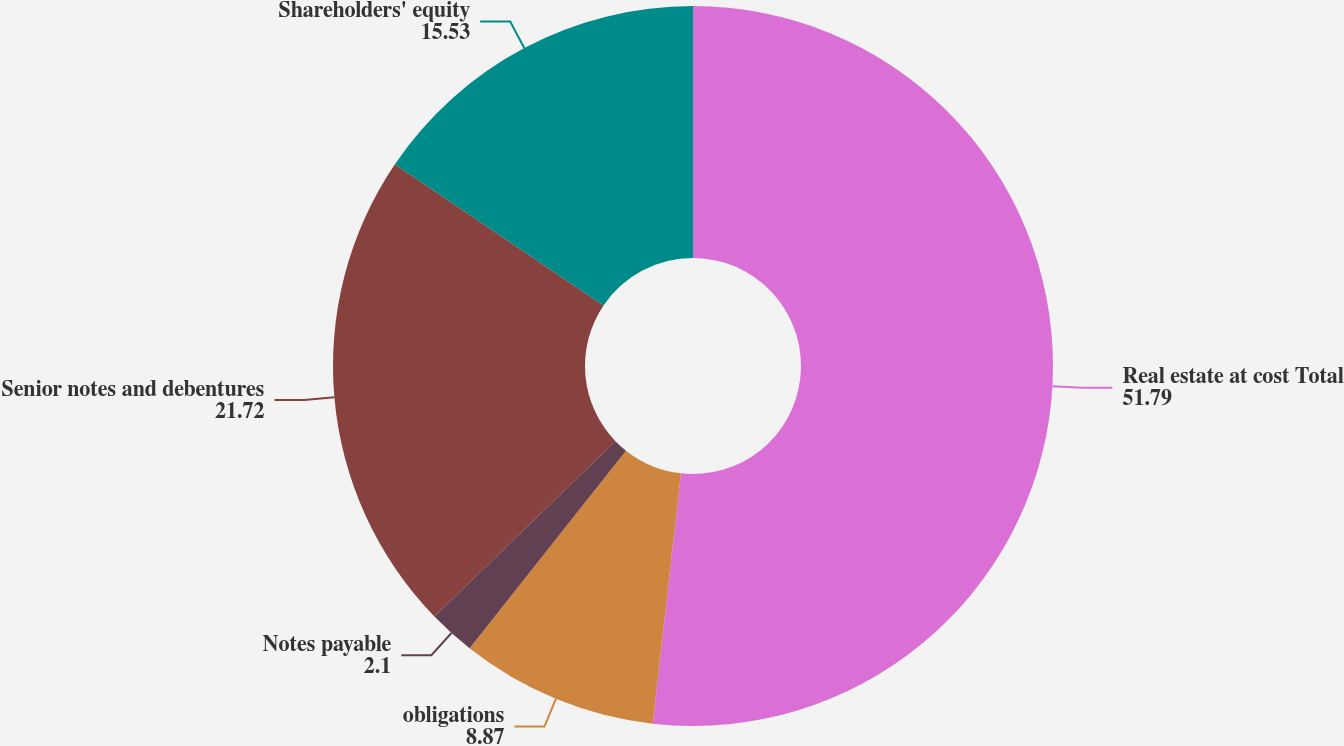Convert chart. <chart><loc_0><loc_0><loc_500><loc_500><pie_chart><fcel>Real estate at cost Total<fcel>obligations<fcel>Notes payable<fcel>Senior notes and debentures<fcel>Shareholders' equity<nl><fcel>51.79%<fcel>8.87%<fcel>2.1%<fcel>21.72%<fcel>15.53%<nl></chart> 